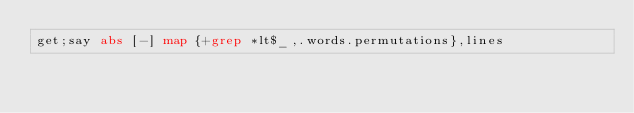Convert code to text. <code><loc_0><loc_0><loc_500><loc_500><_Perl_>get;say abs [-] map {+grep *lt$_,.words.permutations},lines</code> 